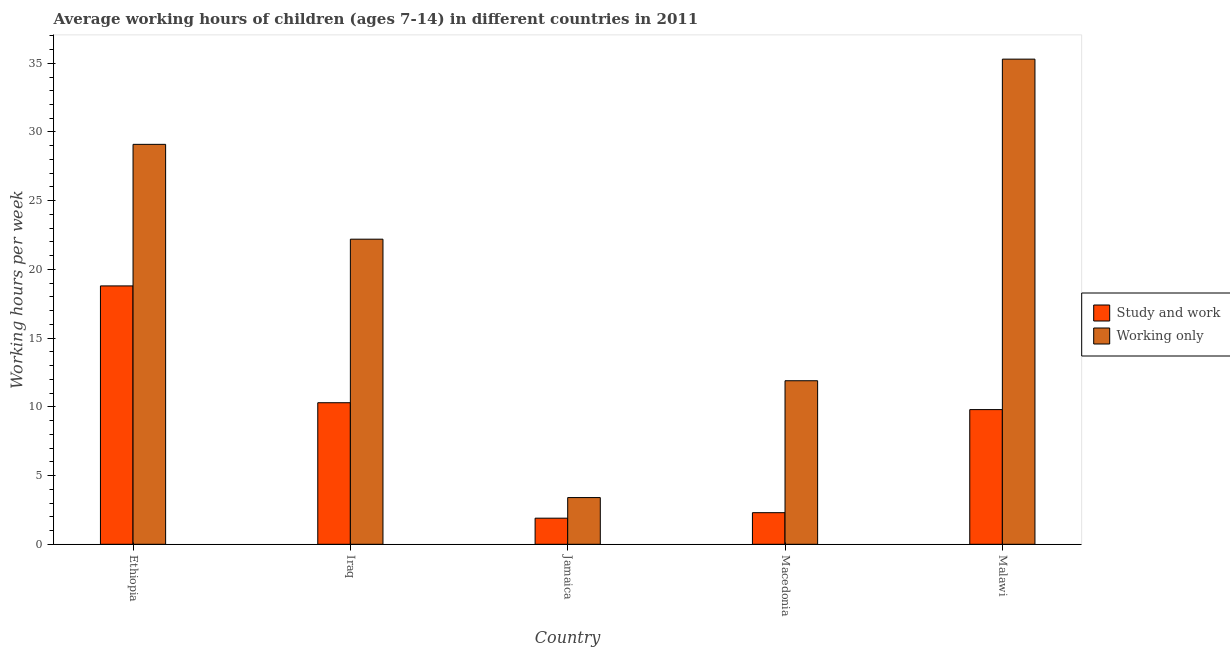How many different coloured bars are there?
Offer a terse response. 2. How many groups of bars are there?
Offer a very short reply. 5. Are the number of bars per tick equal to the number of legend labels?
Ensure brevity in your answer.  Yes. Are the number of bars on each tick of the X-axis equal?
Provide a short and direct response. Yes. How many bars are there on the 2nd tick from the right?
Offer a very short reply. 2. What is the label of the 4th group of bars from the left?
Your response must be concise. Macedonia. In how many cases, is the number of bars for a given country not equal to the number of legend labels?
Offer a terse response. 0. What is the average working hour of children involved in only work in Jamaica?
Offer a very short reply. 3.4. In which country was the average working hour of children involved in only work maximum?
Offer a very short reply. Malawi. In which country was the average working hour of children involved in only work minimum?
Offer a very short reply. Jamaica. What is the total average working hour of children involved in only work in the graph?
Provide a succinct answer. 101.9. What is the difference between the average working hour of children involved in only work in Jamaica and that in Macedonia?
Your response must be concise. -8.5. What is the average average working hour of children involved in only work per country?
Offer a terse response. 20.38. What is the difference between the average working hour of children involved in study and work and average working hour of children involved in only work in Ethiopia?
Provide a succinct answer. -10.3. In how many countries, is the average working hour of children involved in only work greater than 1 hours?
Ensure brevity in your answer.  5. What is the ratio of the average working hour of children involved in study and work in Jamaica to that in Macedonia?
Ensure brevity in your answer.  0.83. Is the average working hour of children involved in study and work in Iraq less than that in Macedonia?
Offer a very short reply. No. What is the difference between the highest and the lowest average working hour of children involved in study and work?
Provide a short and direct response. 16.9. In how many countries, is the average working hour of children involved in study and work greater than the average average working hour of children involved in study and work taken over all countries?
Give a very brief answer. 3. Is the sum of the average working hour of children involved in study and work in Jamaica and Macedonia greater than the maximum average working hour of children involved in only work across all countries?
Your answer should be compact. No. What does the 1st bar from the left in Ethiopia represents?
Ensure brevity in your answer.  Study and work. What does the 2nd bar from the right in Malawi represents?
Make the answer very short. Study and work. Are all the bars in the graph horizontal?
Provide a succinct answer. No. How many countries are there in the graph?
Offer a very short reply. 5. What is the difference between two consecutive major ticks on the Y-axis?
Your answer should be compact. 5. Are the values on the major ticks of Y-axis written in scientific E-notation?
Make the answer very short. No. Does the graph contain any zero values?
Give a very brief answer. No. How many legend labels are there?
Provide a succinct answer. 2. What is the title of the graph?
Provide a succinct answer. Average working hours of children (ages 7-14) in different countries in 2011. What is the label or title of the Y-axis?
Your response must be concise. Working hours per week. What is the Working hours per week in Study and work in Ethiopia?
Your answer should be compact. 18.8. What is the Working hours per week in Working only in Ethiopia?
Your response must be concise. 29.1. What is the Working hours per week in Study and work in Malawi?
Offer a very short reply. 9.8. What is the Working hours per week of Working only in Malawi?
Keep it short and to the point. 35.3. Across all countries, what is the maximum Working hours per week in Study and work?
Offer a very short reply. 18.8. Across all countries, what is the maximum Working hours per week of Working only?
Offer a very short reply. 35.3. Across all countries, what is the minimum Working hours per week in Working only?
Your response must be concise. 3.4. What is the total Working hours per week of Study and work in the graph?
Provide a succinct answer. 43.1. What is the total Working hours per week in Working only in the graph?
Offer a very short reply. 101.9. What is the difference between the Working hours per week of Study and work in Ethiopia and that in Iraq?
Give a very brief answer. 8.5. What is the difference between the Working hours per week of Working only in Ethiopia and that in Jamaica?
Keep it short and to the point. 25.7. What is the difference between the Working hours per week in Study and work in Iraq and that in Jamaica?
Keep it short and to the point. 8.4. What is the difference between the Working hours per week in Study and work in Iraq and that in Malawi?
Your answer should be compact. 0.5. What is the difference between the Working hours per week in Working only in Iraq and that in Malawi?
Keep it short and to the point. -13.1. What is the difference between the Working hours per week in Study and work in Jamaica and that in Macedonia?
Your answer should be compact. -0.4. What is the difference between the Working hours per week in Working only in Jamaica and that in Malawi?
Your response must be concise. -31.9. What is the difference between the Working hours per week of Working only in Macedonia and that in Malawi?
Offer a terse response. -23.4. What is the difference between the Working hours per week in Study and work in Ethiopia and the Working hours per week in Working only in Iraq?
Your answer should be compact. -3.4. What is the difference between the Working hours per week in Study and work in Ethiopia and the Working hours per week in Working only in Macedonia?
Your response must be concise. 6.9. What is the difference between the Working hours per week of Study and work in Ethiopia and the Working hours per week of Working only in Malawi?
Your answer should be very brief. -16.5. What is the difference between the Working hours per week of Study and work in Iraq and the Working hours per week of Working only in Jamaica?
Provide a short and direct response. 6.9. What is the difference between the Working hours per week in Study and work in Jamaica and the Working hours per week in Working only in Malawi?
Your response must be concise. -33.4. What is the difference between the Working hours per week of Study and work in Macedonia and the Working hours per week of Working only in Malawi?
Offer a terse response. -33. What is the average Working hours per week of Study and work per country?
Make the answer very short. 8.62. What is the average Working hours per week in Working only per country?
Ensure brevity in your answer.  20.38. What is the difference between the Working hours per week in Study and work and Working hours per week in Working only in Ethiopia?
Your response must be concise. -10.3. What is the difference between the Working hours per week in Study and work and Working hours per week in Working only in Macedonia?
Your answer should be very brief. -9.6. What is the difference between the Working hours per week in Study and work and Working hours per week in Working only in Malawi?
Your response must be concise. -25.5. What is the ratio of the Working hours per week of Study and work in Ethiopia to that in Iraq?
Keep it short and to the point. 1.83. What is the ratio of the Working hours per week in Working only in Ethiopia to that in Iraq?
Offer a terse response. 1.31. What is the ratio of the Working hours per week in Study and work in Ethiopia to that in Jamaica?
Your response must be concise. 9.89. What is the ratio of the Working hours per week in Working only in Ethiopia to that in Jamaica?
Provide a short and direct response. 8.56. What is the ratio of the Working hours per week of Study and work in Ethiopia to that in Macedonia?
Keep it short and to the point. 8.17. What is the ratio of the Working hours per week of Working only in Ethiopia to that in Macedonia?
Your answer should be very brief. 2.45. What is the ratio of the Working hours per week of Study and work in Ethiopia to that in Malawi?
Keep it short and to the point. 1.92. What is the ratio of the Working hours per week of Working only in Ethiopia to that in Malawi?
Ensure brevity in your answer.  0.82. What is the ratio of the Working hours per week in Study and work in Iraq to that in Jamaica?
Your answer should be very brief. 5.42. What is the ratio of the Working hours per week of Working only in Iraq to that in Jamaica?
Ensure brevity in your answer.  6.53. What is the ratio of the Working hours per week in Study and work in Iraq to that in Macedonia?
Provide a short and direct response. 4.48. What is the ratio of the Working hours per week in Working only in Iraq to that in Macedonia?
Make the answer very short. 1.87. What is the ratio of the Working hours per week in Study and work in Iraq to that in Malawi?
Make the answer very short. 1.05. What is the ratio of the Working hours per week of Working only in Iraq to that in Malawi?
Make the answer very short. 0.63. What is the ratio of the Working hours per week in Study and work in Jamaica to that in Macedonia?
Make the answer very short. 0.83. What is the ratio of the Working hours per week of Working only in Jamaica to that in Macedonia?
Your answer should be compact. 0.29. What is the ratio of the Working hours per week of Study and work in Jamaica to that in Malawi?
Ensure brevity in your answer.  0.19. What is the ratio of the Working hours per week in Working only in Jamaica to that in Malawi?
Provide a short and direct response. 0.1. What is the ratio of the Working hours per week of Study and work in Macedonia to that in Malawi?
Make the answer very short. 0.23. What is the ratio of the Working hours per week in Working only in Macedonia to that in Malawi?
Keep it short and to the point. 0.34. What is the difference between the highest and the second highest Working hours per week in Working only?
Your answer should be compact. 6.2. What is the difference between the highest and the lowest Working hours per week of Working only?
Offer a terse response. 31.9. 